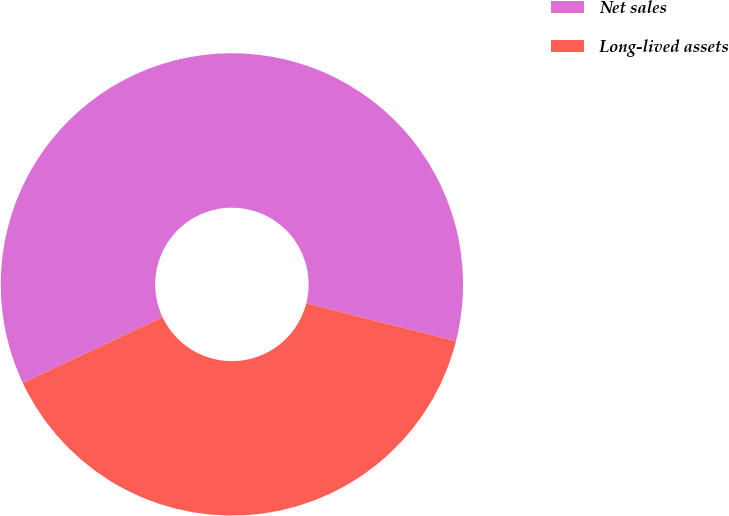Convert chart to OTSL. <chart><loc_0><loc_0><loc_500><loc_500><pie_chart><fcel>Net sales<fcel>Long-lived assets<nl><fcel>60.97%<fcel>39.03%<nl></chart> 